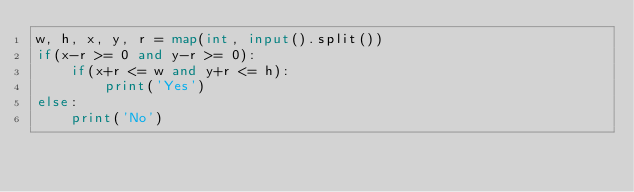<code> <loc_0><loc_0><loc_500><loc_500><_Python_>w, h, x, y, r = map(int, input().split())
if(x-r >= 0 and y-r >= 0):
    if(x+r <= w and y+r <= h):
        print('Yes')
else:
    print('No')</code> 